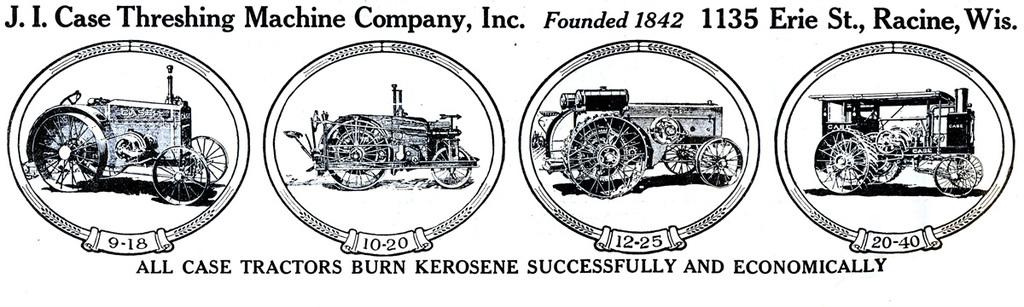What type of drawings are in the image? The image contains sketches of tractors. Are there any numerical elements in the image? Yes, there are numbers present in the image. What type of written information is visible in the image? There is text visible in the image. How many ladybugs can be seen on the tractors in the image? There are no ladybugs present in the image; it contains sketches of tractors and other elements. 